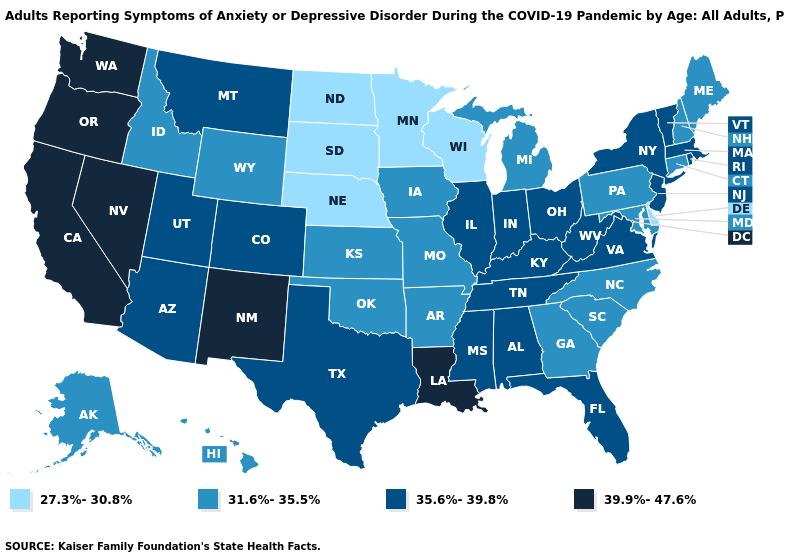Which states have the lowest value in the USA?
Short answer required. Delaware, Minnesota, Nebraska, North Dakota, South Dakota, Wisconsin. Name the states that have a value in the range 35.6%-39.8%?
Short answer required. Alabama, Arizona, Colorado, Florida, Illinois, Indiana, Kentucky, Massachusetts, Mississippi, Montana, New Jersey, New York, Ohio, Rhode Island, Tennessee, Texas, Utah, Vermont, Virginia, West Virginia. Does Alaska have the lowest value in the West?
Quick response, please. Yes. Name the states that have a value in the range 39.9%-47.6%?
Write a very short answer. California, Louisiana, Nevada, New Mexico, Oregon, Washington. Is the legend a continuous bar?
Give a very brief answer. No. Name the states that have a value in the range 35.6%-39.8%?
Answer briefly. Alabama, Arizona, Colorado, Florida, Illinois, Indiana, Kentucky, Massachusetts, Mississippi, Montana, New Jersey, New York, Ohio, Rhode Island, Tennessee, Texas, Utah, Vermont, Virginia, West Virginia. What is the highest value in states that border Nevada?
Concise answer only. 39.9%-47.6%. What is the highest value in states that border Illinois?
Keep it brief. 35.6%-39.8%. Among the states that border Maine , which have the lowest value?
Be succinct. New Hampshire. How many symbols are there in the legend?
Concise answer only. 4. Name the states that have a value in the range 35.6%-39.8%?
Concise answer only. Alabama, Arizona, Colorado, Florida, Illinois, Indiana, Kentucky, Massachusetts, Mississippi, Montana, New Jersey, New York, Ohio, Rhode Island, Tennessee, Texas, Utah, Vermont, Virginia, West Virginia. Name the states that have a value in the range 27.3%-30.8%?
Keep it brief. Delaware, Minnesota, Nebraska, North Dakota, South Dakota, Wisconsin. Name the states that have a value in the range 27.3%-30.8%?
Concise answer only. Delaware, Minnesota, Nebraska, North Dakota, South Dakota, Wisconsin. Name the states that have a value in the range 35.6%-39.8%?
Give a very brief answer. Alabama, Arizona, Colorado, Florida, Illinois, Indiana, Kentucky, Massachusetts, Mississippi, Montana, New Jersey, New York, Ohio, Rhode Island, Tennessee, Texas, Utah, Vermont, Virginia, West Virginia. Name the states that have a value in the range 27.3%-30.8%?
Concise answer only. Delaware, Minnesota, Nebraska, North Dakota, South Dakota, Wisconsin. 